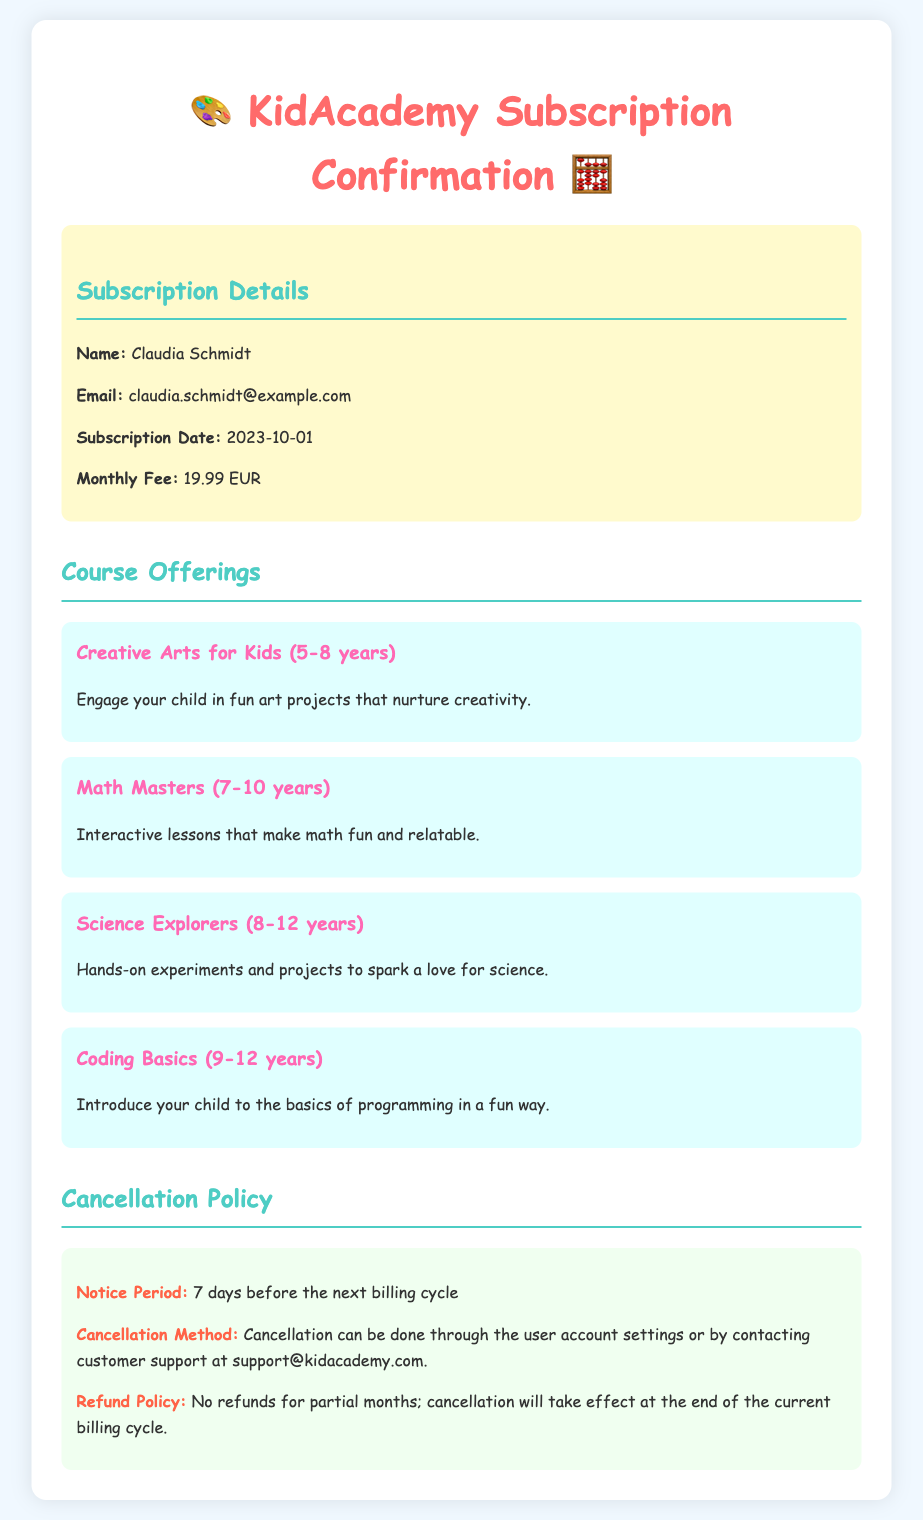What is the name of the subscriber? The subscriber's name is listed at the top of the subscription details section.
Answer: Claudia Schmidt What is the email address provided? The email address is mentioned in the user info section, next to the subscriber's name.
Answer: claudia.schmidt@example.com When was the subscription date? The subscription date is clearly specified in the user info section of the document.
Answer: 2023-10-01 What is the monthly fee for the subscription? The monthly fee is stated in the subscription details section.
Answer: 19.99 EUR What age range is the "Creative Arts for Kids" course designed for? The age range for this course is explicitly mentioned within the course offerings section.
Answer: 5-8 years What is the cancellation notice period? The cancellation notice period is highlighted in the cancellation policy section.
Answer: 7 days before the next billing cycle How can cancellation be done? The cancellation method is provided in the cancellation policy, detailing the avenues available for cancelling.
Answer: User account settings or by contacting customer support Is there a refund policy for partial months? The document explicitly states the refund policy regarding partial months in the cancellation policy section.
Answer: No refunds for partial months 